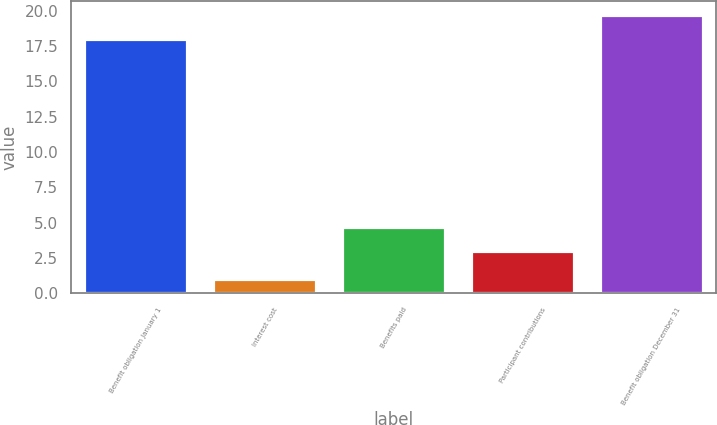Convert chart to OTSL. <chart><loc_0><loc_0><loc_500><loc_500><bar_chart><fcel>Benefit obligation January 1<fcel>Interest cost<fcel>Benefits paid<fcel>Participant contributions<fcel>Benefit obligation December 31<nl><fcel>18<fcel>1<fcel>4.7<fcel>3<fcel>19.7<nl></chart> 